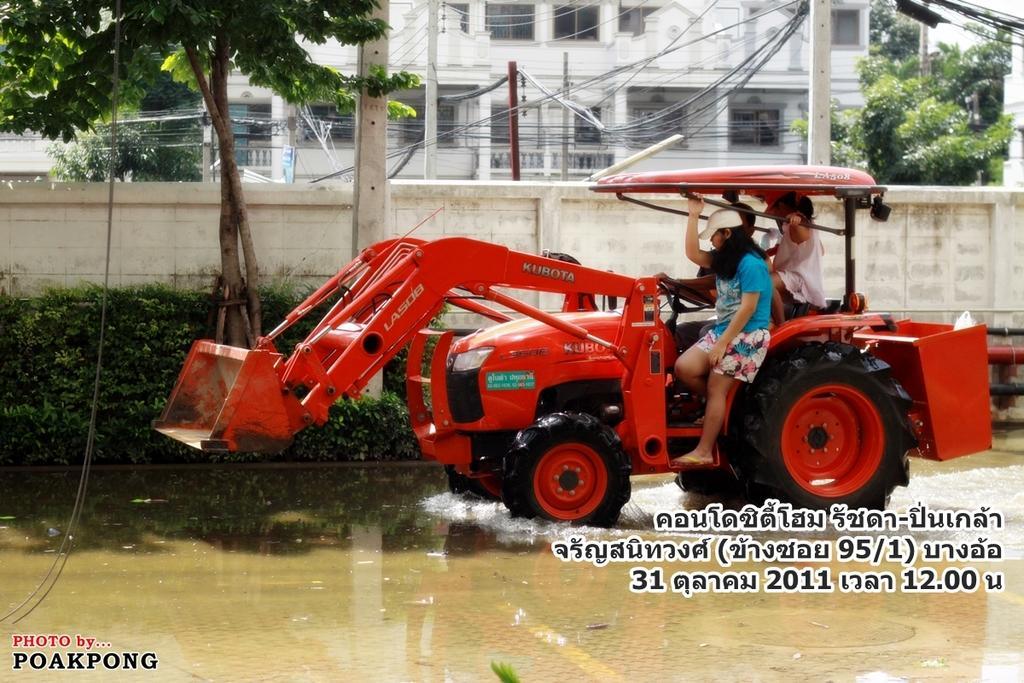Please provide a concise description of this image. In this image there is a vehicle and we can see people sitting in the vehicle. In the background there are trees, poles, wires and buildings. There is a hedge. At the bottom there is water. 